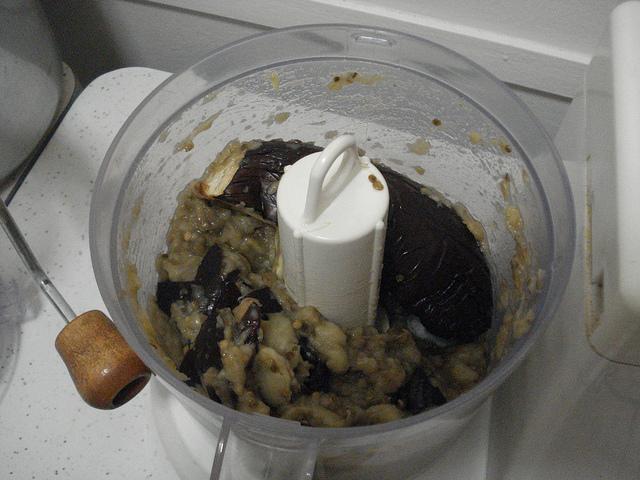Is this a healthy ingredient?
Give a very brief answer. No. On what material is the appliance sitting?
Quick response, please. Blender. What is this machine is being used to make?
Short answer required. Smoothie. What is this appliance used for?
Be succinct. Blending. Is that cookie dough?
Short answer required. No. What is in the bowl?
Write a very short answer. Food. 